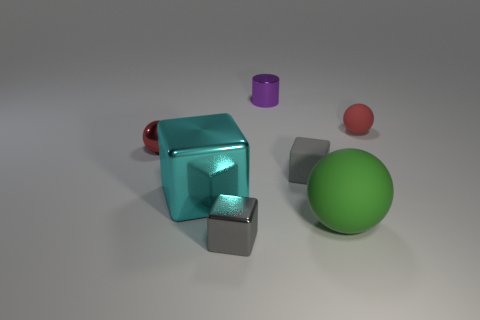Subtract all tiny red matte balls. How many balls are left? 2 Subtract all gray cubes. How many red balls are left? 2 Subtract all green balls. How many balls are left? 2 Subtract 1 blocks. How many blocks are left? 2 Add 2 green things. How many objects exist? 9 Subtract all cubes. How many objects are left? 4 Subtract all cyan cubes. Subtract all cyan balls. How many cubes are left? 2 Subtract all tiny green shiny balls. Subtract all gray cubes. How many objects are left? 5 Add 1 tiny gray blocks. How many tiny gray blocks are left? 3 Add 5 cyan blocks. How many cyan blocks exist? 6 